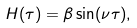<formula> <loc_0><loc_0><loc_500><loc_500>H ( \tau ) = \beta \sin ( \nu \tau ) ,</formula> 